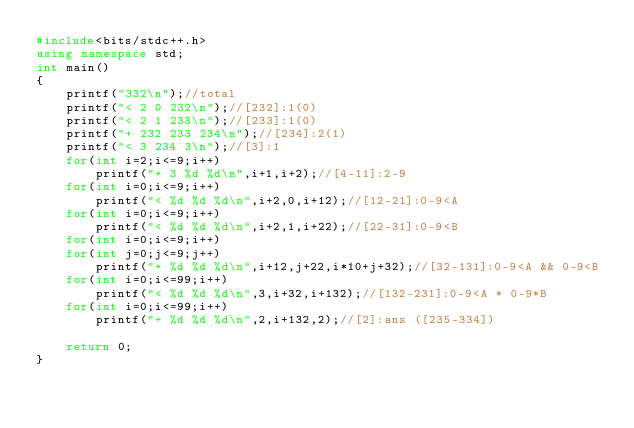Convert code to text. <code><loc_0><loc_0><loc_500><loc_500><_C++_>#include<bits/stdc++.h>
using namespace std;
int main()
{
	printf("332\n");//total
	printf("< 2 0 232\n");//[232]:1(0)
	printf("< 2 1 233\n");//[233]:1(0)
	printf("+ 232 233 234\n");//[234]:2(1)
	printf("< 3 234 3\n");//[3]:1
	for(int i=2;i<=9;i++)
		printf("+ 3 %d %d\n",i+1,i+2);//[4-11]:2-9
	for(int i=0;i<=9;i++)
		printf("< %d %d %d\n",i+2,0,i+12);//[12-21]:0-9<A
	for(int i=0;i<=9;i++)
		printf("< %d %d %d\n",i+2,1,i+22);//[22-31]:0-9<B
	for(int i=0;i<=9;i++)
	for(int j=0;j<=9;j++)
		printf("+ %d %d %d\n",i+12,j+22,i*10+j+32);//[32-131]:0-9<A && 0-9<B
	for(int i=0;i<=99;i++)
		printf("< %d %d %d\n",3,i+32,i+132);//[132-231]:0-9<A * 0-9*B
	for(int i=0;i<=99;i++)
		printf("+ %d %d %d\n",2,i+132,2);//[2]:ans ([235-334])
	
	return 0;
}</code> 